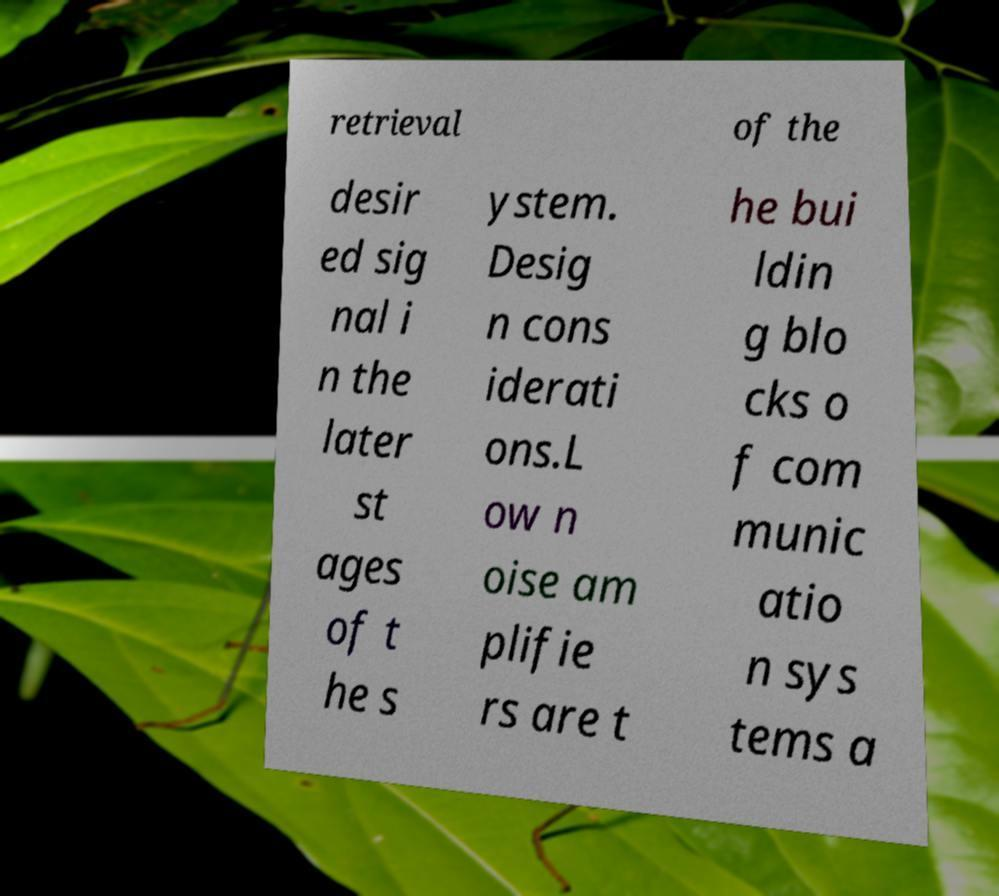Can you read and provide the text displayed in the image?This photo seems to have some interesting text. Can you extract and type it out for me? retrieval of the desir ed sig nal i n the later st ages of t he s ystem. Desig n cons iderati ons.L ow n oise am plifie rs are t he bui ldin g blo cks o f com munic atio n sys tems a 